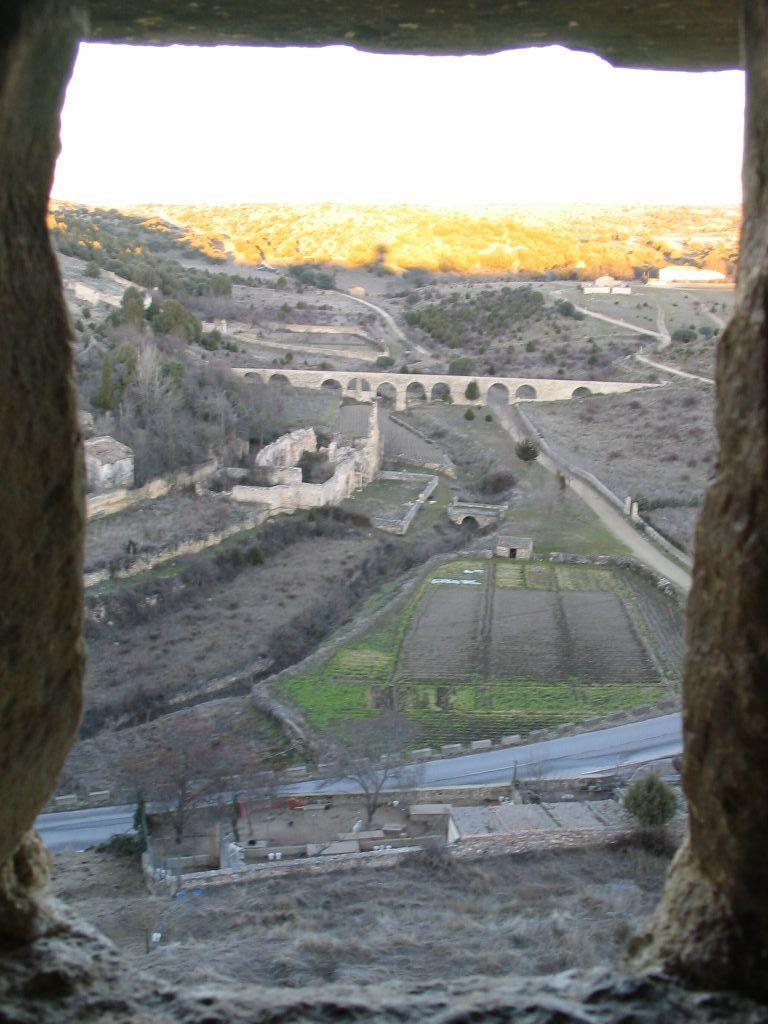What can be seen in the image? There is a view in the image, which includes buildings, trees, land, and grass. Can you describe the landscape in the image? The landscape in the image features buildings, trees, land, and grass. Are there any natural elements present in the image? Yes, there are trees and grass, which are natural elements. What type of stocking can be seen hanging from the gate in the image? There is no gate or stocking present in the image. What letters are visible on the buildings in the image? The provided facts do not mention any letters on the buildings, so we cannot determine if any letters are visible. 